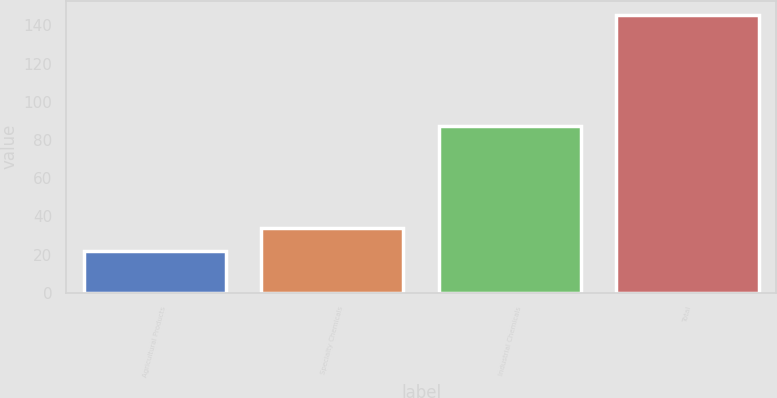Convert chart to OTSL. <chart><loc_0><loc_0><loc_500><loc_500><bar_chart><fcel>Agricultural Products<fcel>Specialty Chemicals<fcel>Industrial Chemicals<fcel>Total<nl><fcel>21.6<fcel>34<fcel>87.3<fcel>145.6<nl></chart> 